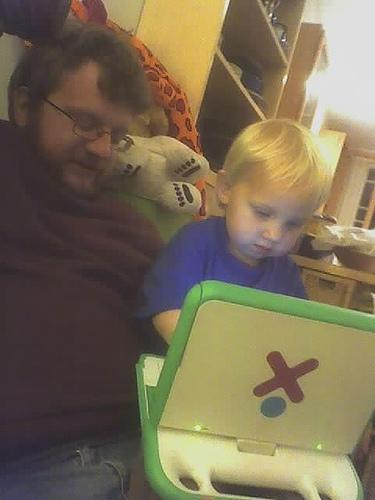What kind of action is the boy taking?

Choices:
A) typing
B) throwing
C) running
D) kicking typing 